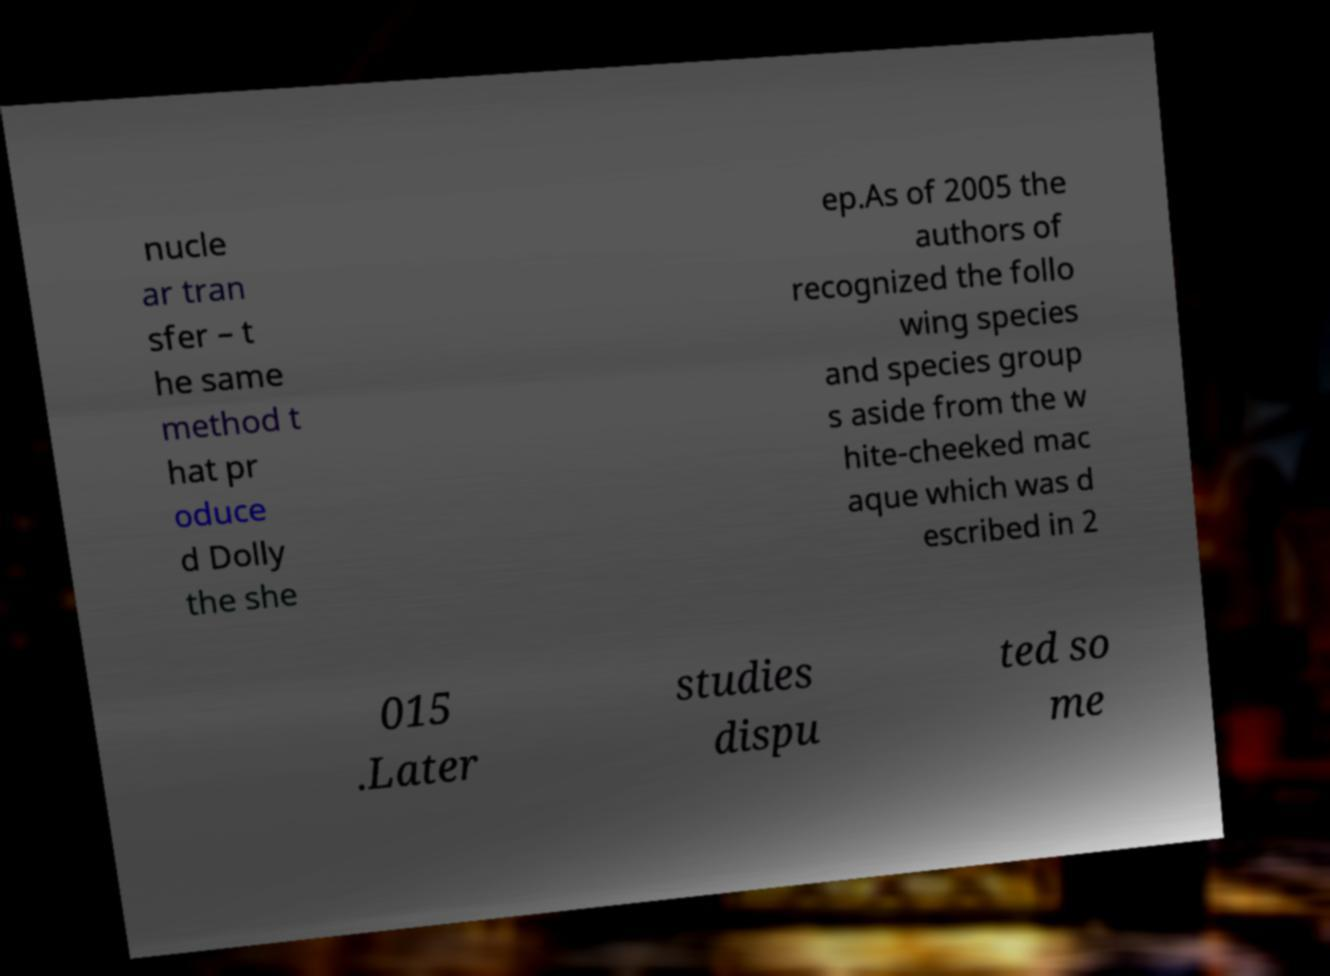Please identify and transcribe the text found in this image. nucle ar tran sfer – t he same method t hat pr oduce d Dolly the she ep.As of 2005 the authors of recognized the follo wing species and species group s aside from the w hite-cheeked mac aque which was d escribed in 2 015 .Later studies dispu ted so me 